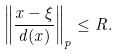Convert formula to latex. <formula><loc_0><loc_0><loc_500><loc_500>\left \| \frac { x - \xi } { d ( x ) } \right \| _ { p } \leq R .</formula> 